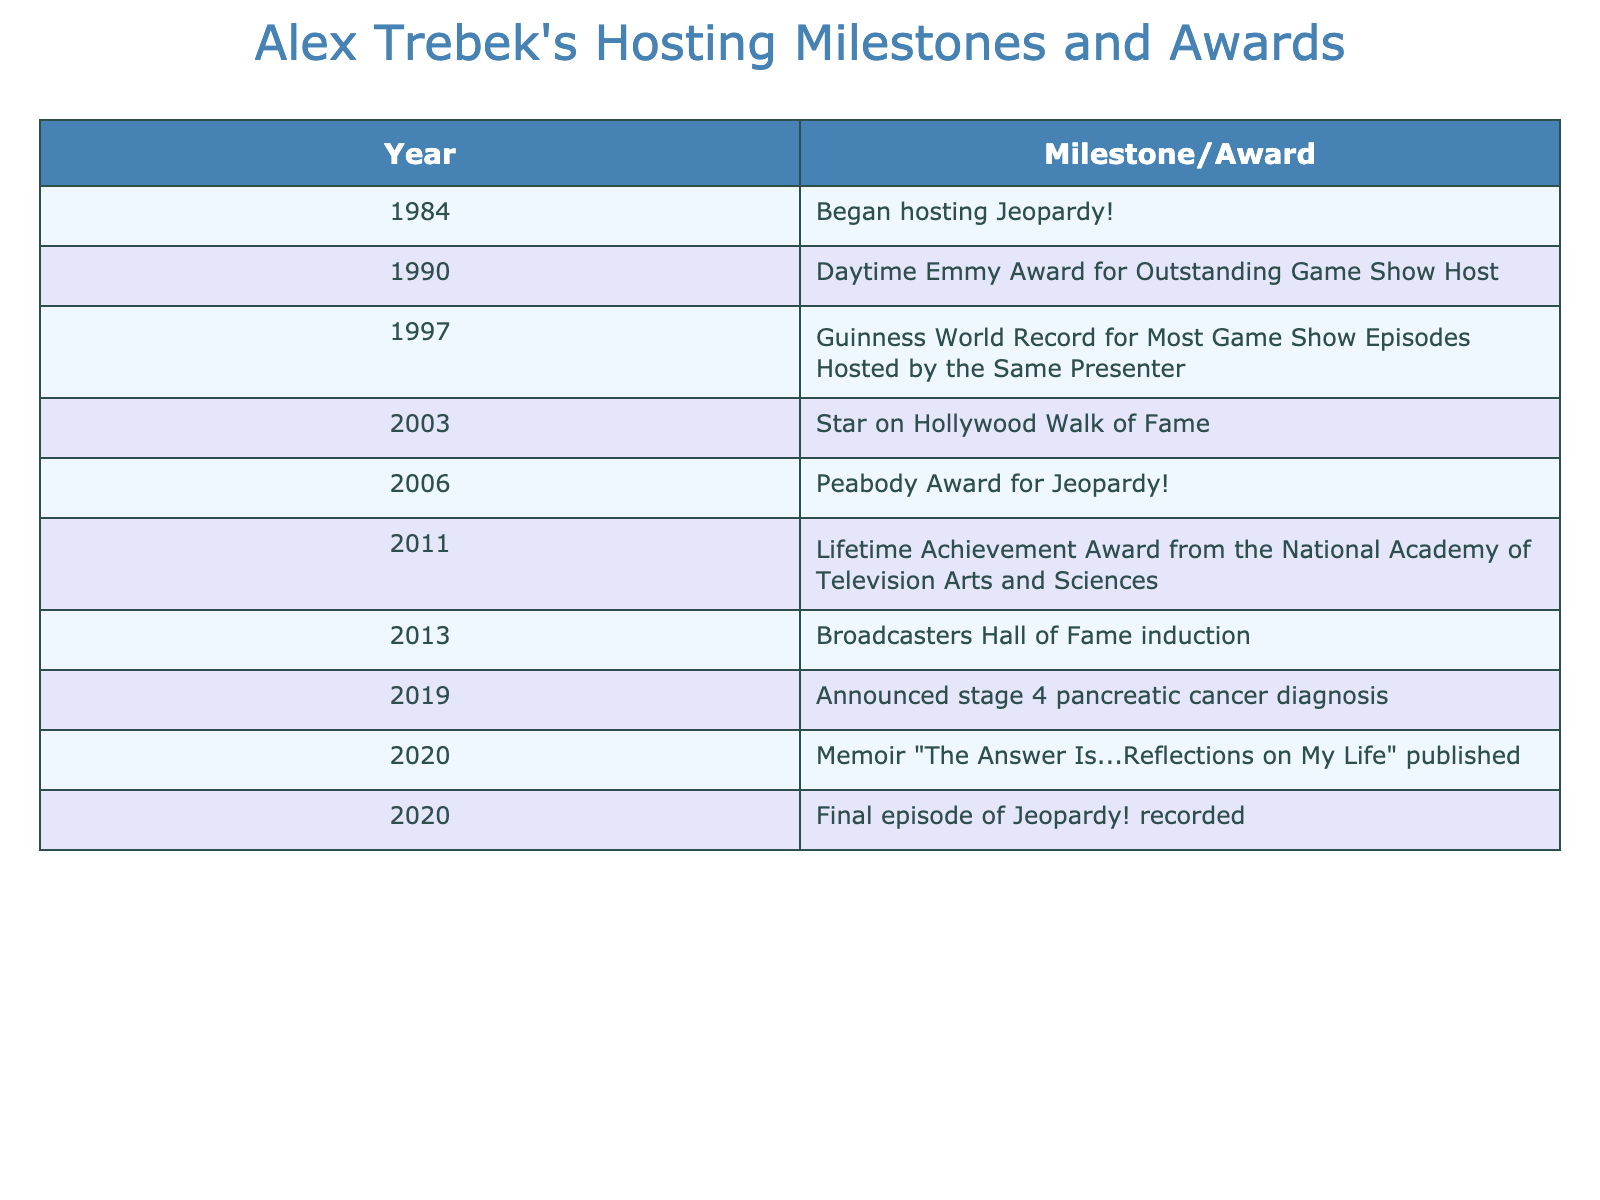What year did Alex Trebek begin hosting Jeopardy!? The table shows that Alex Trebek began hosting Jeopardy! in 1984.
Answer: 1984 What milestone did Alex Trebek achieve in 1990? According to the table, the milestone achieved by Alex Trebek in 1990 was receiving the Daytime Emmy Award for Outstanding Game Show Host.
Answer: Daytime Emmy Award for Outstanding Game Show Host How many milestones or awards did Alex Trebek receive in total? By counting the entries in the table, we can see that there are a total of 9 milestones or awards listed.
Answer: 9 In which year did Alex Trebek receive a star on the Hollywood Walk of Fame? The table indicates that the star on the Hollywood Walk of Fame was awarded to Alex Trebek in 2003.
Answer: 2003 Which milestone or award was given to Alex Trebek in 2011? The milestone listed for Alex Trebek in 2011 is the Lifetime Achievement Award from the National Academy of Television Arts and Sciences.
Answer: Lifetime Achievement Award from the National Academy of Television Arts and Sciences What is the difference in years between Alex Trebek's hosting debut and his final episode recording? Trebek began hosting in 1984 and recorded his final episode in 2020. The difference is 2020 - 1984 = 36 years.
Answer: 36 years True or False: Alex Trebek announced his cancer diagnosis before publishing his memoir. The table lists the announcement of his cancer diagnosis in 2019 and the publication of his memoir in 2020, confirming that he did announce his cancer diagnosis before publishing.
Answer: True How many years passed between the Daytime Emmy Award and the Peabody Award? The Daytime Emmy Award was received in 1990 and the Peabody Award in 2006. The number of years between these two events is 2006 - 1990 = 16 years.
Answer: 16 years Which award or milestone is the third listed in the table and in what year was it awarded? The third milestone listed in the table is the Guinness World Record for Most Game Show Episodes Hosted by the Same Presenter, awarded in 1997.
Answer: Guinness World Record for Most Game Show Episodes Hosted by the Same Presenter in 1997 What milestones did Alex Trebek achieve between 2000 and 2010? The milestones achieved by Alex Trebek during that time frame listed in the table are the Peabody Award in 2006 and the Lifetime Achievement Award in 2011. However, since the latter is outside the given timeframe, the only one between 2000 and 2010 is the Peabody Award in 2006.
Answer: Peabody Award in 2006 